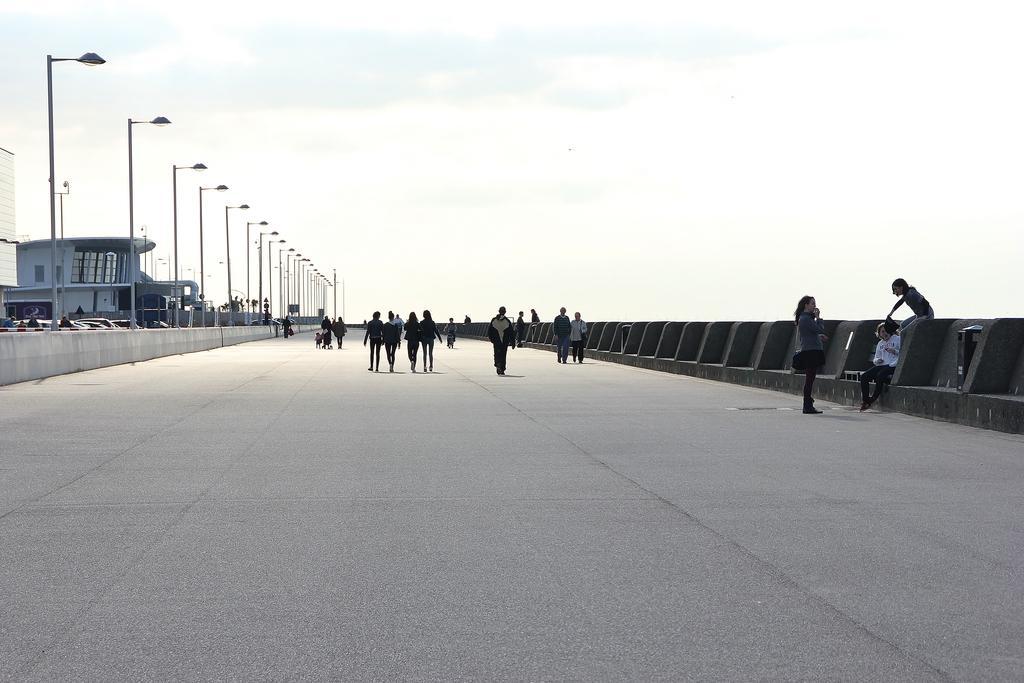Can you describe this image briefly? In this image there are group of persons standing and walking. On the right side there is a person sitting. On the left side there are poles, buildings and trees and the sky is cloudy. 